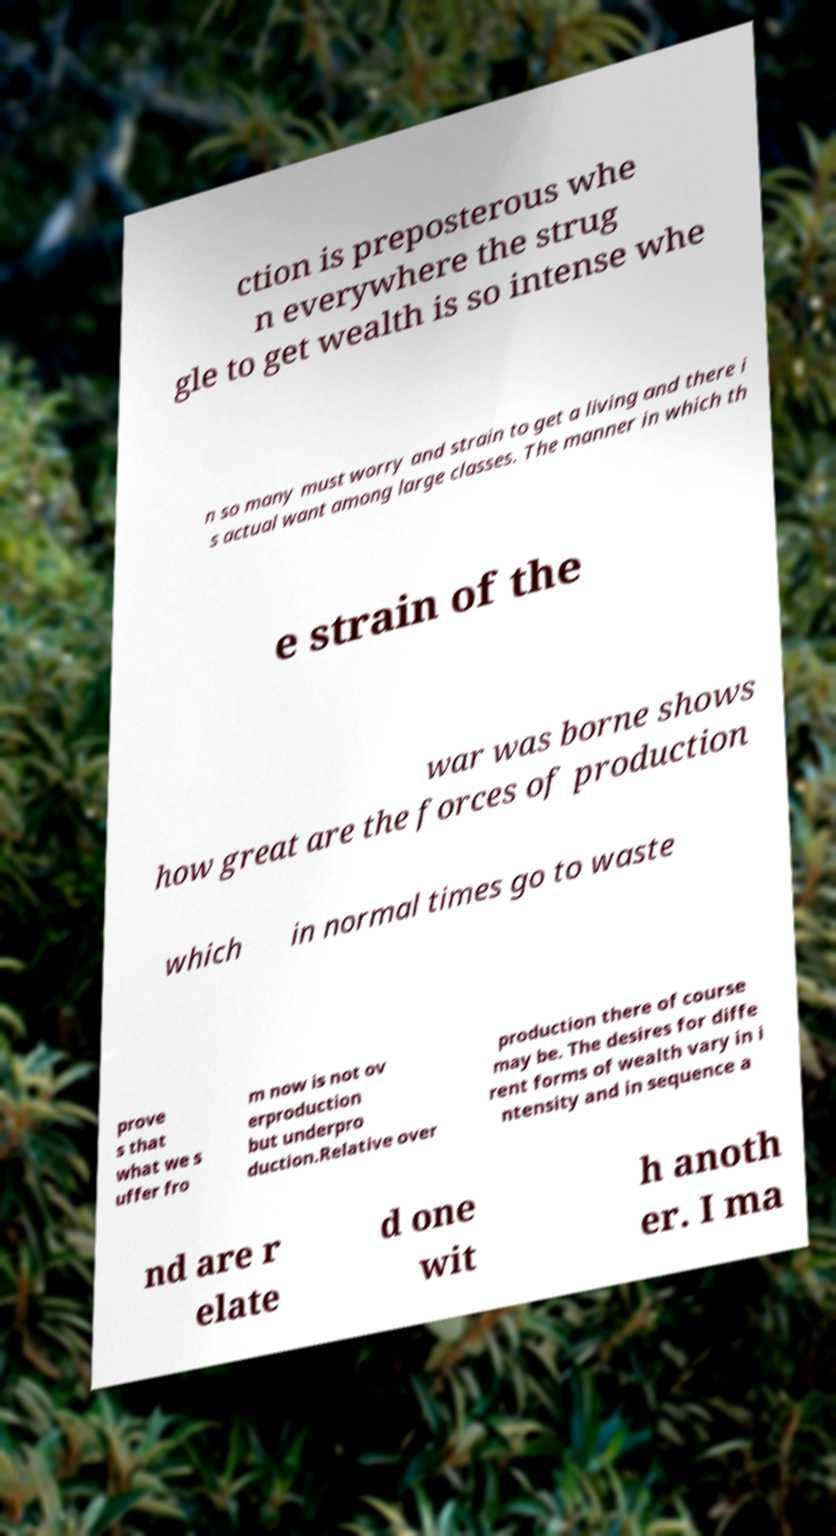Can you accurately transcribe the text from the provided image for me? ction is preposterous whe n everywhere the strug gle to get wealth is so intense whe n so many must worry and strain to get a living and there i s actual want among large classes. The manner in which th e strain of the war was borne shows how great are the forces of production which in normal times go to waste prove s that what we s uffer fro m now is not ov erproduction but underpro duction.Relative over production there of course may be. The desires for diffe rent forms of wealth vary in i ntensity and in sequence a nd are r elate d one wit h anoth er. I ma 